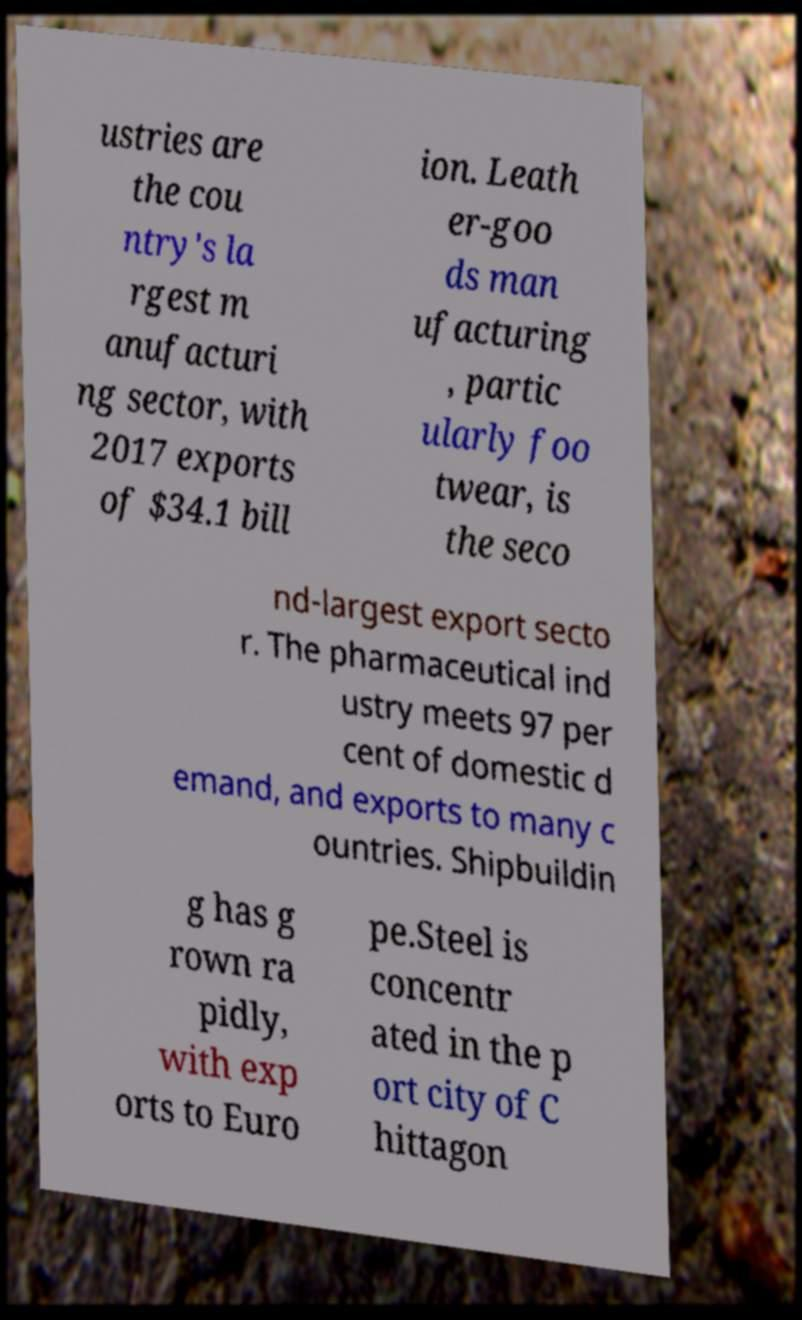Could you assist in decoding the text presented in this image and type it out clearly? ustries are the cou ntry's la rgest m anufacturi ng sector, with 2017 exports of $34.1 bill ion. Leath er-goo ds man ufacturing , partic ularly foo twear, is the seco nd-largest export secto r. The pharmaceutical ind ustry meets 97 per cent of domestic d emand, and exports to many c ountries. Shipbuildin g has g rown ra pidly, with exp orts to Euro pe.Steel is concentr ated in the p ort city of C hittagon 